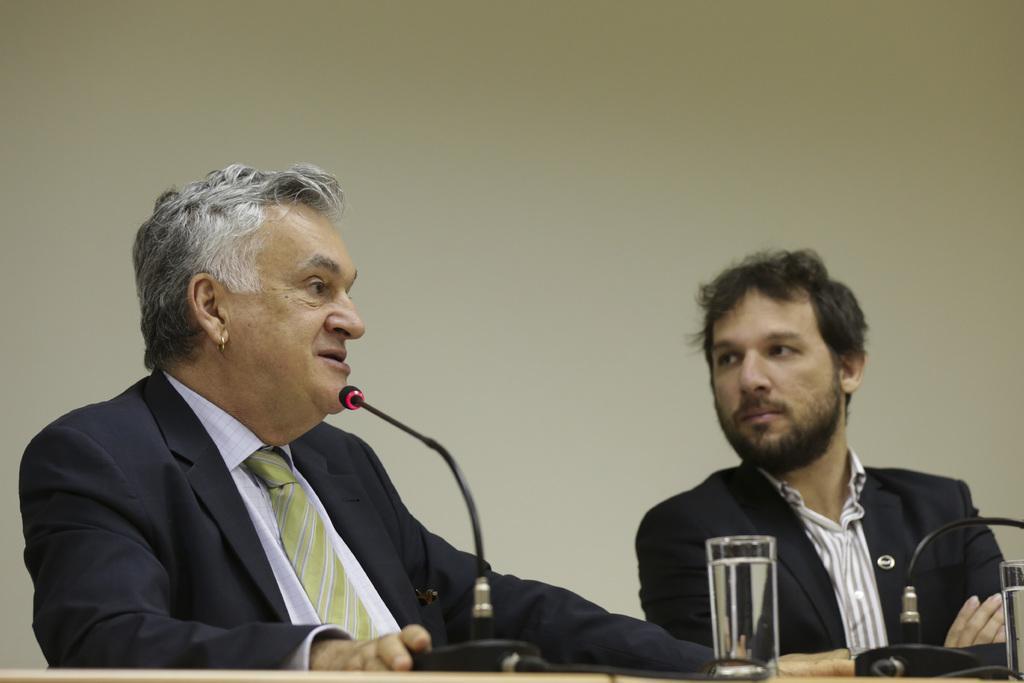Please provide a concise description of this image. In this picture there are two men sitting besides a table. On the table there are glasses and mike's. Person towards the left, he is wearing a tie and person towards the right wearing a blazer and staring at the another person. 